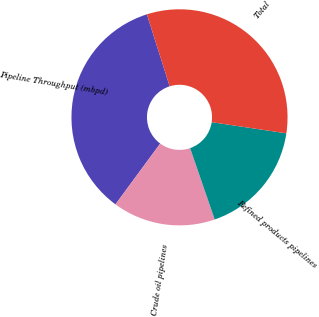Convert chart to OTSL. <chart><loc_0><loc_0><loc_500><loc_500><pie_chart><fcel>Pipeline Throughput (mbpd)<fcel>Crude oil pipelines<fcel>Refined products pipelines<fcel>Total<nl><fcel>35.02%<fcel>15.38%<fcel>17.35%<fcel>32.25%<nl></chart> 